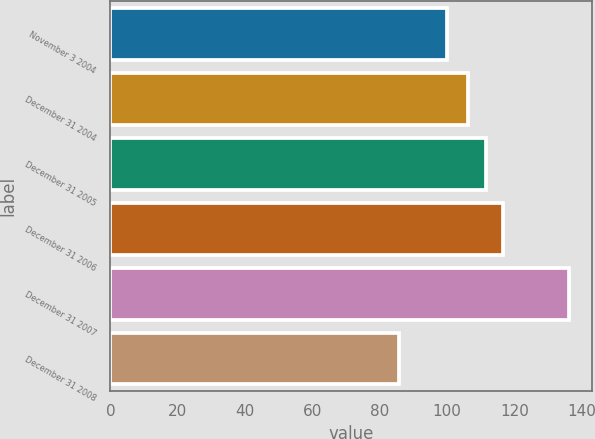Convert chart. <chart><loc_0><loc_0><loc_500><loc_500><bar_chart><fcel>November 3 2004<fcel>December 31 2004<fcel>December 31 2005<fcel>December 31 2006<fcel>December 31 2007<fcel>December 31 2008<nl><fcel>100<fcel>106.3<fcel>111.6<fcel>116.67<fcel>136.3<fcel>85.6<nl></chart> 